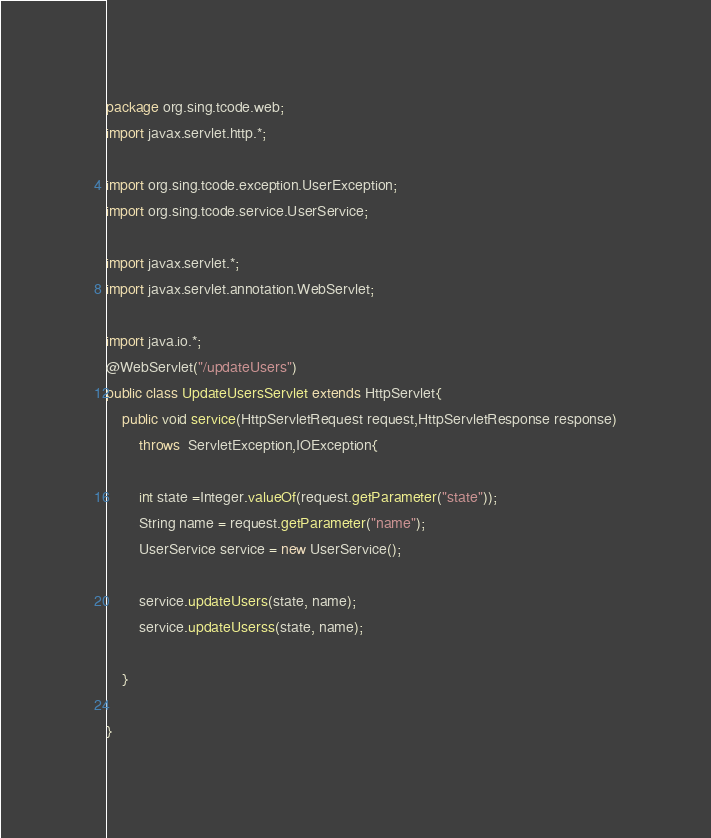<code> <loc_0><loc_0><loc_500><loc_500><_Java_>package org.sing.tcode.web;
import javax.servlet.http.*;

import org.sing.tcode.exception.UserException;
import org.sing.tcode.service.UserService;

import javax.servlet.*;
import javax.servlet.annotation.WebServlet;

import java.io.*;
@WebServlet("/updateUsers")
public class UpdateUsersServlet extends HttpServlet{
	public void service(HttpServletRequest request,HttpServletResponse response)
		throws  ServletException,IOException{
		
		int state =Integer.valueOf(request.getParameter("state"));
		String name = request.getParameter("name");
		UserService service = new UserService();
	 
		service.updateUsers(state, name);
		service.updateUserss(state, name);
		
	}
	
}
</code> 